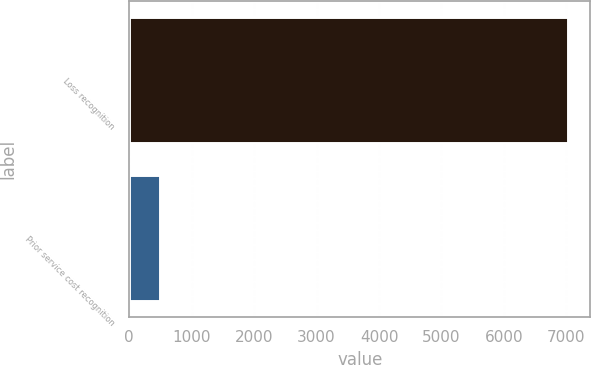Convert chart. <chart><loc_0><loc_0><loc_500><loc_500><bar_chart><fcel>Loss recognition<fcel>Prior service cost recognition<nl><fcel>7031<fcel>490<nl></chart> 